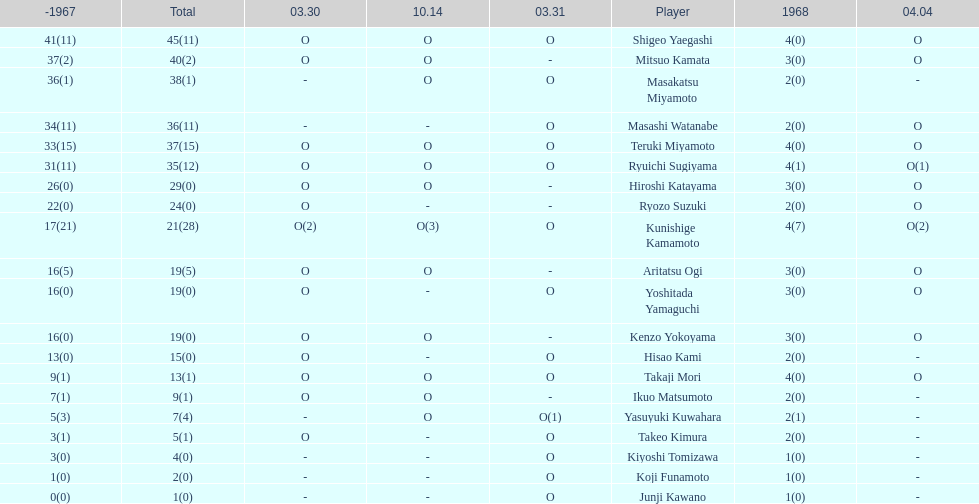How many total did mitsuo kamata have? 40(2). 